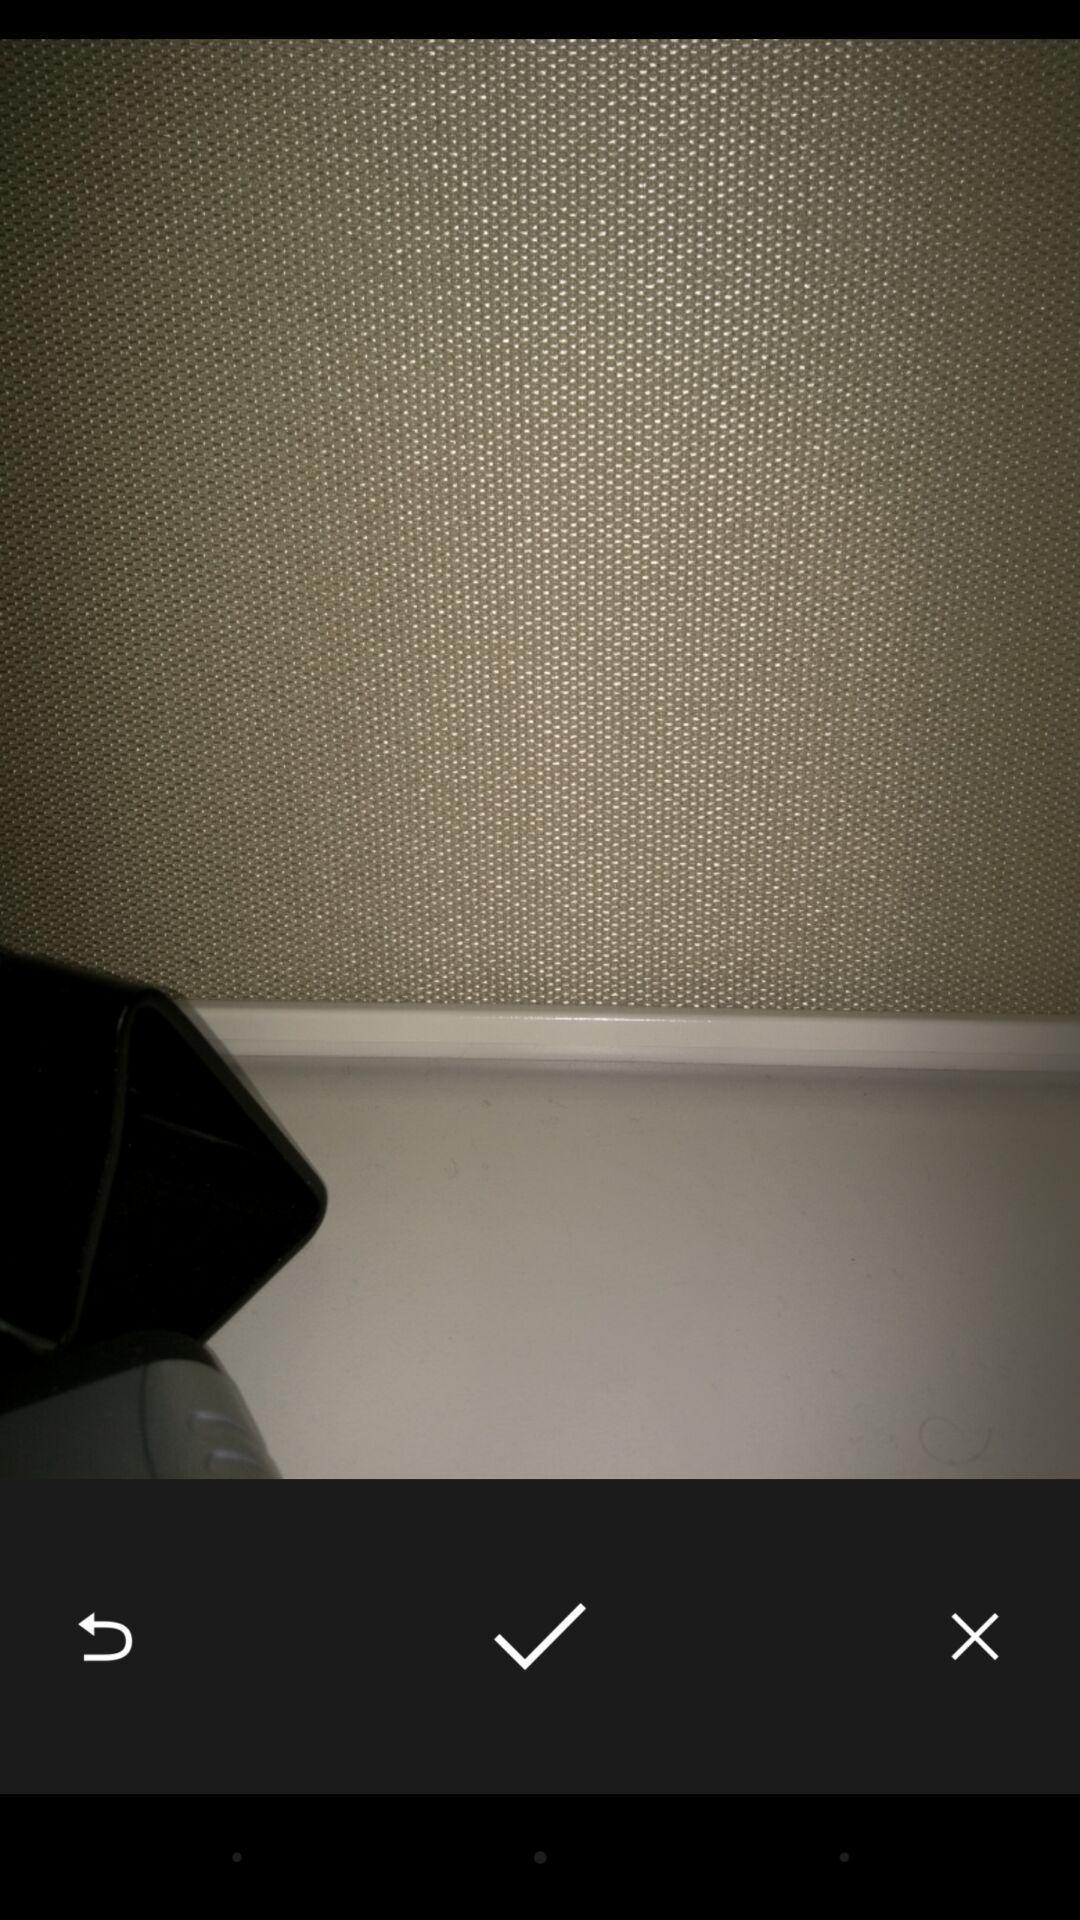Summarize the main components in this picture. Screen shows a image options. 